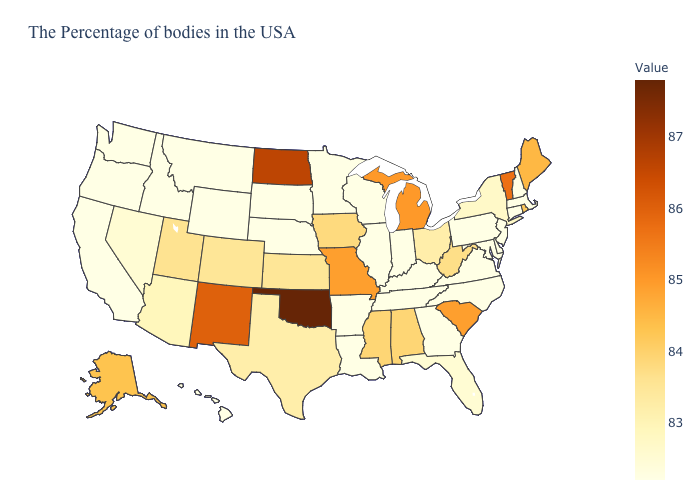Does New York have the highest value in the USA?
Answer briefly. No. Which states have the lowest value in the USA?
Give a very brief answer. Massachusetts, New Hampshire, Connecticut, New Jersey, Delaware, Maryland, Pennsylvania, Virginia, North Carolina, Georgia, Kentucky, Indiana, Tennessee, Wisconsin, Illinois, Louisiana, Arkansas, Minnesota, Nebraska, South Dakota, Wyoming, Montana, Idaho, California, Washington, Oregon, Hawaii. Does Maine have the lowest value in the USA?
Keep it brief. No. Among the states that border Wisconsin , does Minnesota have the highest value?
Keep it brief. No. Does Kansas have a higher value than Alaska?
Write a very short answer. No. Which states hav the highest value in the Northeast?
Write a very short answer. Vermont. Does Alaska have the lowest value in the USA?
Give a very brief answer. No. Among the states that border Illinois , does Wisconsin have the lowest value?
Quick response, please. Yes. 